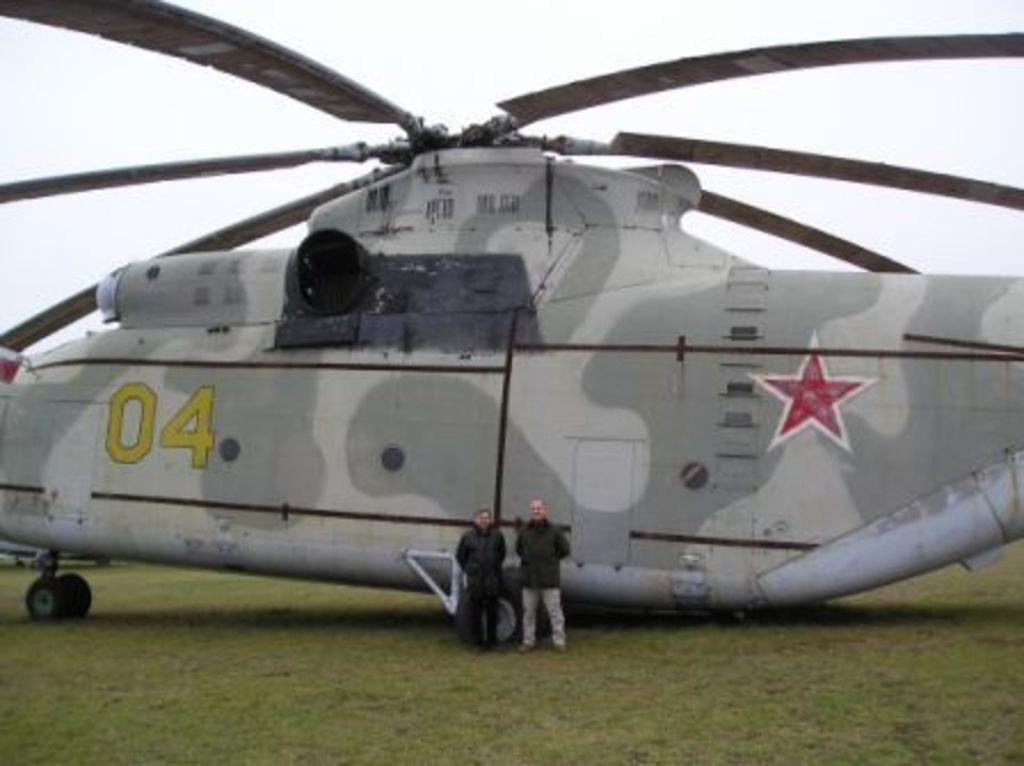<image>
Provide a brief description of the given image. the number 04 is on the helicopter outside 